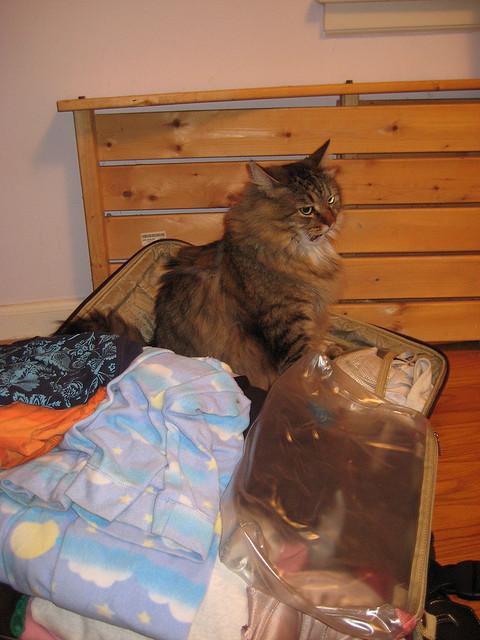Is the cat playing?
Short answer required. No. What color is the cat?
Keep it brief. Brown. How many cats are there?
Concise answer only. 1. What is the cat sitting inside of?
Write a very short answer. Suitcase. What breed is the cat?
Give a very brief answer. Normal. What type of pictures are on the purple blanket?
Short answer required. Clouds. 